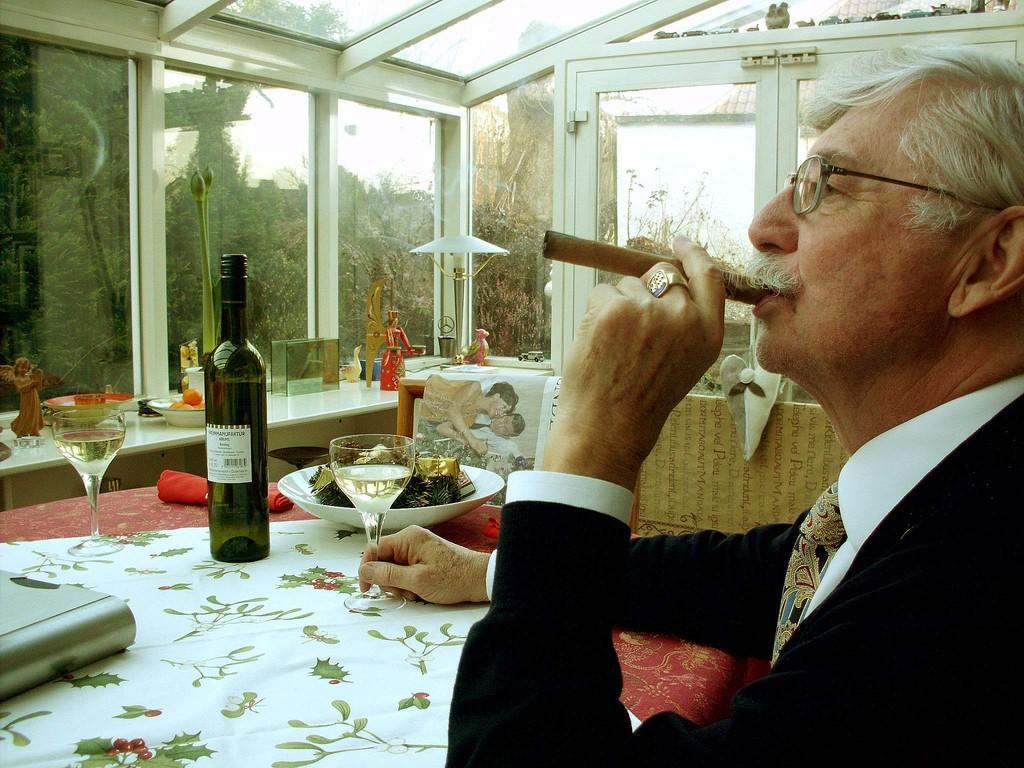Can you describe this image briefly? In this picture there is a person sitting and holding the glass with his right hand and holding cigarette with his left hand. There are bottles,glasses, plates, bowls on the table. At the back there is a door. The table is covered with red and white color cloth. 